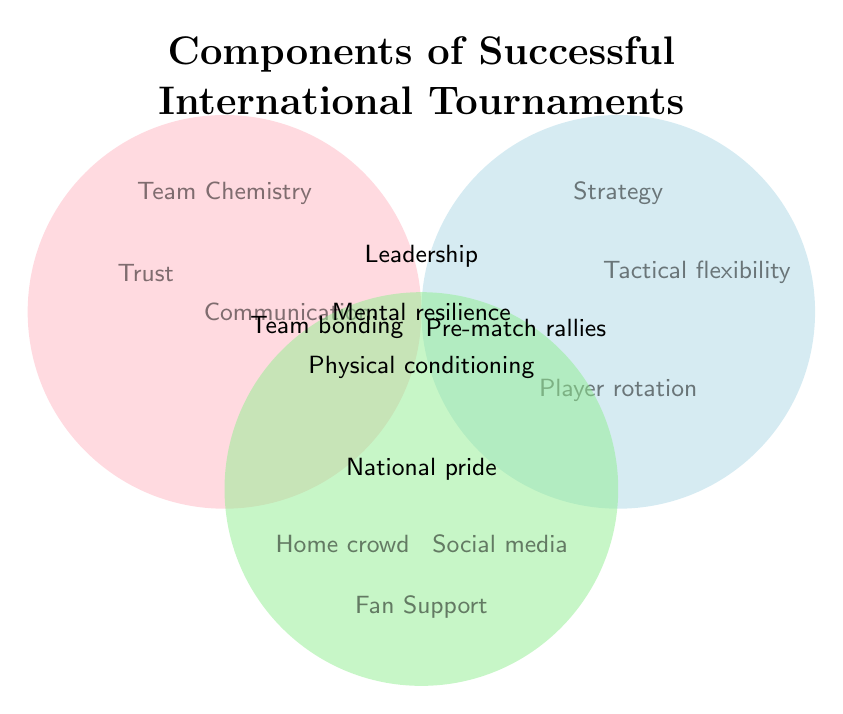What are the three main categories shown in the Venn Diagram? The Venn Diagram shows three overlapping circles, each labeled differently. The three labels are "Team Chemistry," "Strategy," and "Fan Support."
Answer: Team Chemistry, Strategy, Fan Support Which component is shared by all three categories? At the intersection of all three circles, "Team Chemistry," "Strategy," and "Fan Support," there is one component listed. This component is "Leadership."
Answer: Leadership What components are unique to the Team Chemistry category? Look for items within the "Team Chemistry" circle that do not overlap with the other circles. These components are “Shared experiences,” “Trust,” and “Communication.”
Answer: Shared experiences, Trust, Communication Which components are shared between Team Chemistry and Strategy but not with Fan Support? Look at the overlapping area between the "Team Chemistry" and "Strategy" circles that does not intersect with the "Fan Support" circle. The component listed here is "Team bonding activities."
Answer: Team bonding activities Are there any components shared between Fan Support and Strategy but not with Team Chemistry? Check the overlapping section between the "Strategy" and "Fan Support" circles that does not overlap with the "Team Chemistry" circle. The component listed here is "Pre-match rallies."
Answer: Pre-match rallies What are the shared components between Team Chemistry and Fan Support? Look at the overlapping area between the "Team Chemistry" and "Fan Support" circles. The component listed here is "National pride."
Answer: National pride How many components are listed in the Strategy category? Count the number of components listed inside the "Strategy" circle, including those that overlap with other circles. The components are "Tactical flexibility," "Player rotation," "Set-piece planning," "Team bonding activities," "Pre-match rallies," "Leadership," "Mental resilience," and "Physical conditioning." There are 8 components in total.
Answer: 8 Which categories share the component "Physical conditioning"? Identify the intersection area where "Physical conditioning" is placed. It is in the center where all three circles "Team Chemistry," "Strategy," and "Fan Support" overlap.
Answer: All three categories Which component in the Team Chemistry category relates to player trust and collaboration? Refer to the labels within the "Team Chemistry" circle. The components are "Shared experiences," "Trust," and "Communication," directly relating to player trust and collaboration.
Answer: Trust and Communication 